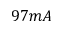<formula> <loc_0><loc_0><loc_500><loc_500>9 7 m A</formula> 